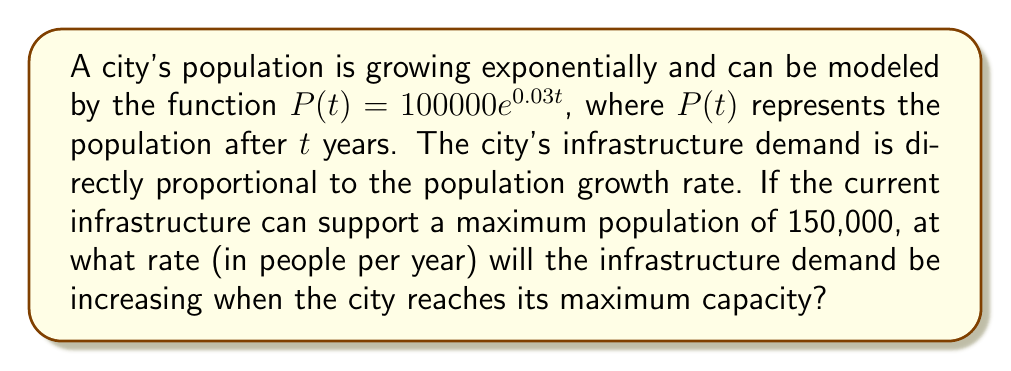Solve this math problem. To solve this problem, we need to follow these steps:

1) First, we need to find when the population reaches 150,000. We can do this by solving the equation:

   $150000 = 100000e^{0.03t}$

2) Dividing both sides by 100000:

   $1.5 = e^{0.03t}$

3) Taking the natural log of both sides:

   $\ln(1.5) = 0.03t$

4) Solving for t:

   $t = \frac{\ln(1.5)}{0.03} \approx 13.53$ years

5) Now, we need to find the rate of population growth at this time. The rate of growth is given by the derivative of the population function:

   $\frac{dP}{dt} = 100000 \cdot 0.03e^{0.03t}$

6) At $t = 13.53$, the population growth rate is:

   $\frac{dP}{dt} = 100000 \cdot 0.03e^{0.03(13.53)} = 100000 \cdot 0.03 \cdot 1.5 = 4500$

Therefore, when the city reaches its maximum capacity, the infrastructure demand will be increasing at a rate of 4500 people per year.
Answer: 4500 people/year 